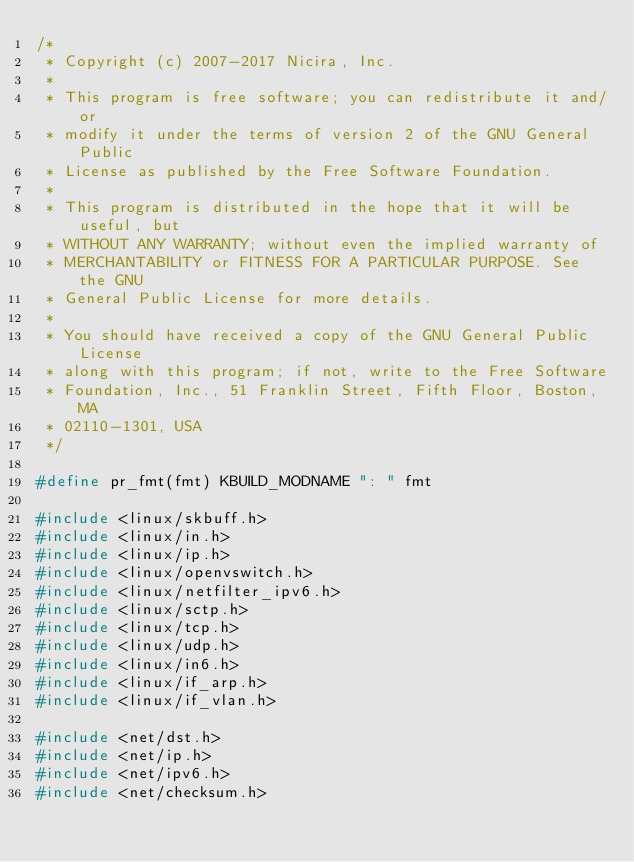Convert code to text. <code><loc_0><loc_0><loc_500><loc_500><_C_>/*
 * Copyright (c) 2007-2017 Nicira, Inc.
 *
 * This program is free software; you can redistribute it and/or
 * modify it under the terms of version 2 of the GNU General Public
 * License as published by the Free Software Foundation.
 *
 * This program is distributed in the hope that it will be useful, but
 * WITHOUT ANY WARRANTY; without even the implied warranty of
 * MERCHANTABILITY or FITNESS FOR A PARTICULAR PURPOSE. See the GNU
 * General Public License for more details.
 *
 * You should have received a copy of the GNU General Public License
 * along with this program; if not, write to the Free Software
 * Foundation, Inc., 51 Franklin Street, Fifth Floor, Boston, MA
 * 02110-1301, USA
 */

#define pr_fmt(fmt) KBUILD_MODNAME ": " fmt

#include <linux/skbuff.h>
#include <linux/in.h>
#include <linux/ip.h>
#include <linux/openvswitch.h>
#include <linux/netfilter_ipv6.h>
#include <linux/sctp.h>
#include <linux/tcp.h>
#include <linux/udp.h>
#include <linux/in6.h>
#include <linux/if_arp.h>
#include <linux/if_vlan.h>

#include <net/dst.h>
#include <net/ip.h>
#include <net/ipv6.h>
#include <net/checksum.h></code> 